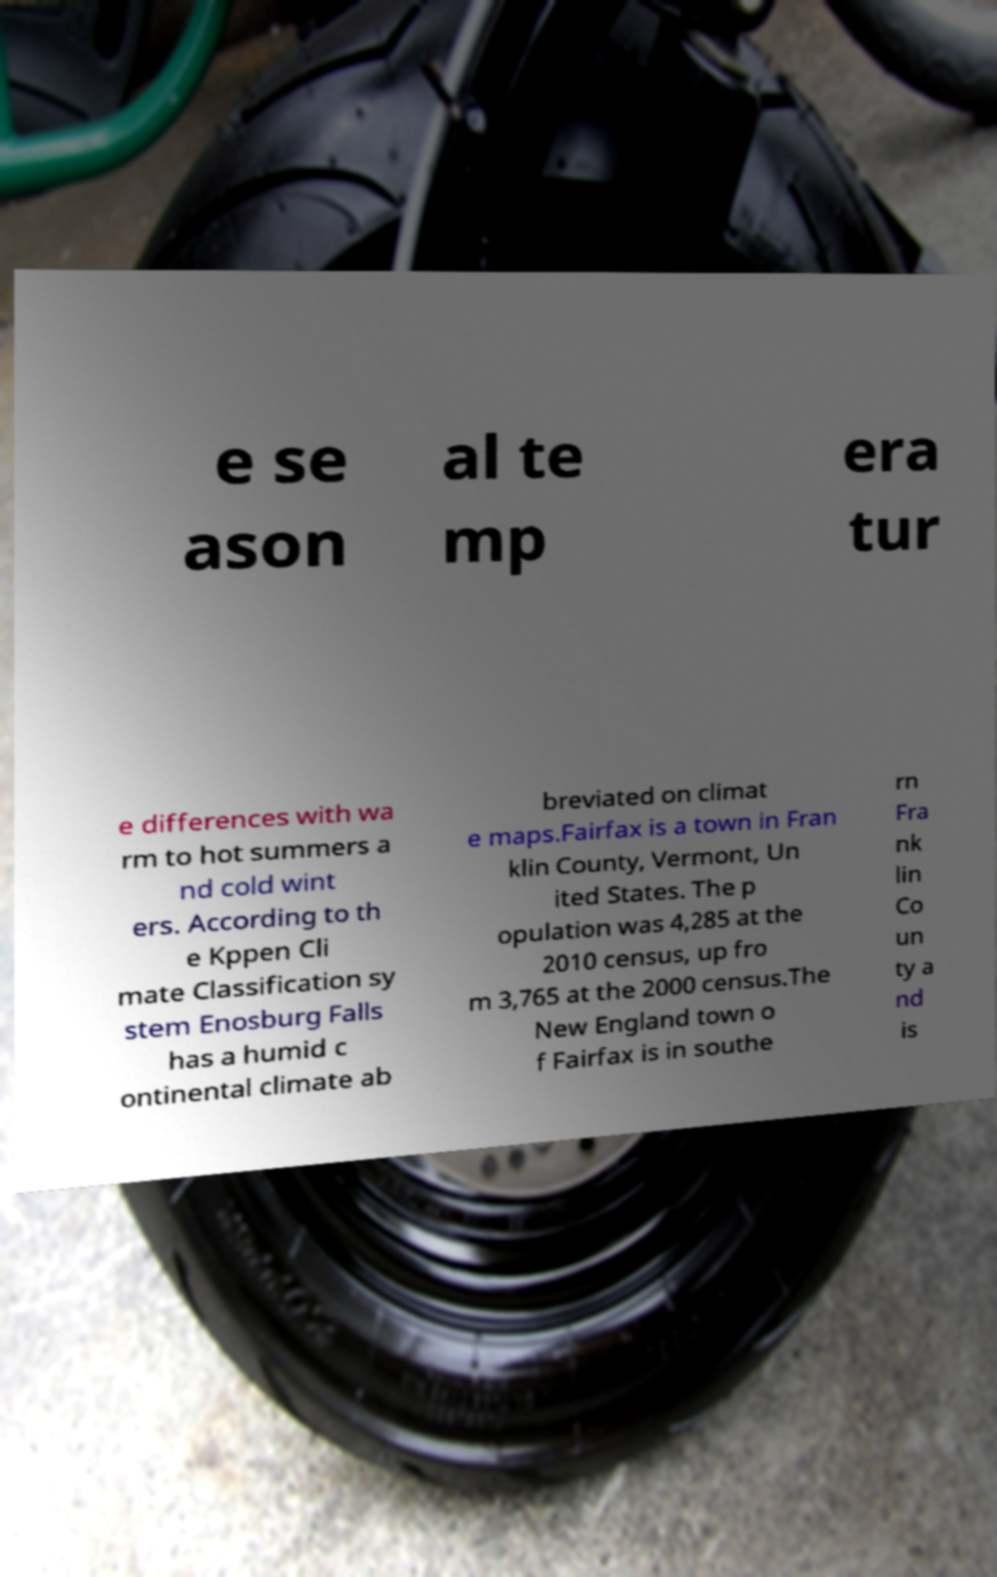Can you accurately transcribe the text from the provided image for me? e se ason al te mp era tur e differences with wa rm to hot summers a nd cold wint ers. According to th e Kppen Cli mate Classification sy stem Enosburg Falls has a humid c ontinental climate ab breviated on climat e maps.Fairfax is a town in Fran klin County, Vermont, Un ited States. The p opulation was 4,285 at the 2010 census, up fro m 3,765 at the 2000 census.The New England town o f Fairfax is in southe rn Fra nk lin Co un ty a nd is 